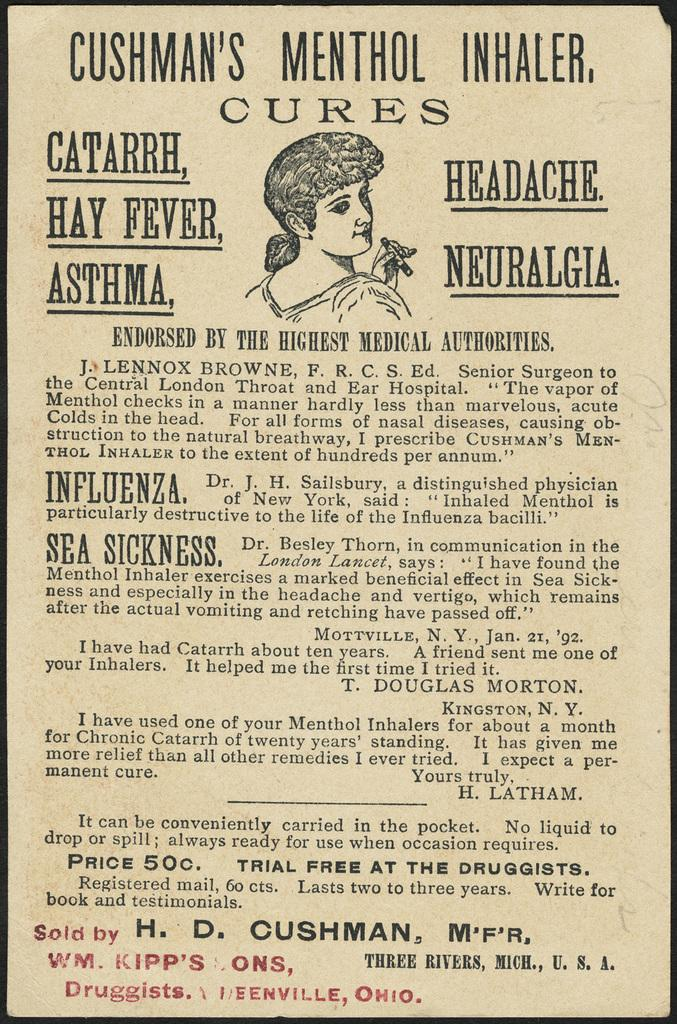What is featured on the poster in the image? There is a poster with text in the image. Can you describe the person in the image? A woman is visible in the image. What is the woman holding in her hand? The woman is holding an object in her hand. What type of bushes can be seen in the image? There are no bushes present in the image. How does the woman plan to crush the object she is holding? There is no indication in the image that the woman is planning to crush the object she is holding. 